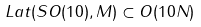Convert formula to latex. <formula><loc_0><loc_0><loc_500><loc_500>L a t ( S O ( 1 0 ) , M ) \subset O ( 1 0 N )</formula> 